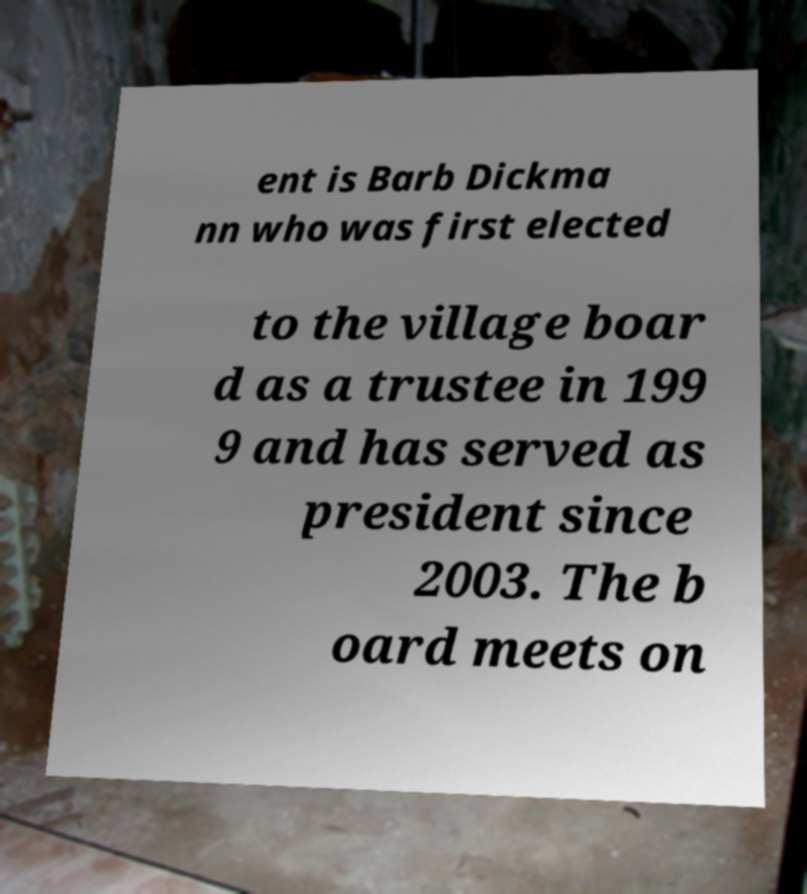What messages or text are displayed in this image? I need them in a readable, typed format. ent is Barb Dickma nn who was first elected to the village boar d as a trustee in 199 9 and has served as president since 2003. The b oard meets on 